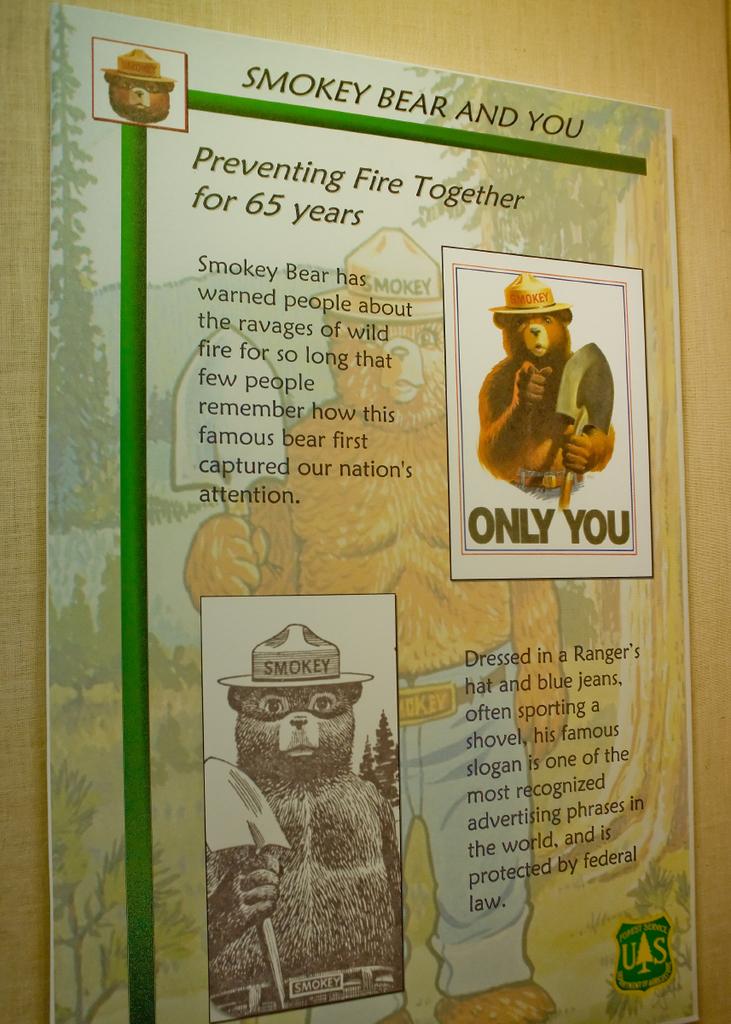Who has warned people about the ravages of wild fire?
Make the answer very short. Smokey bear. 